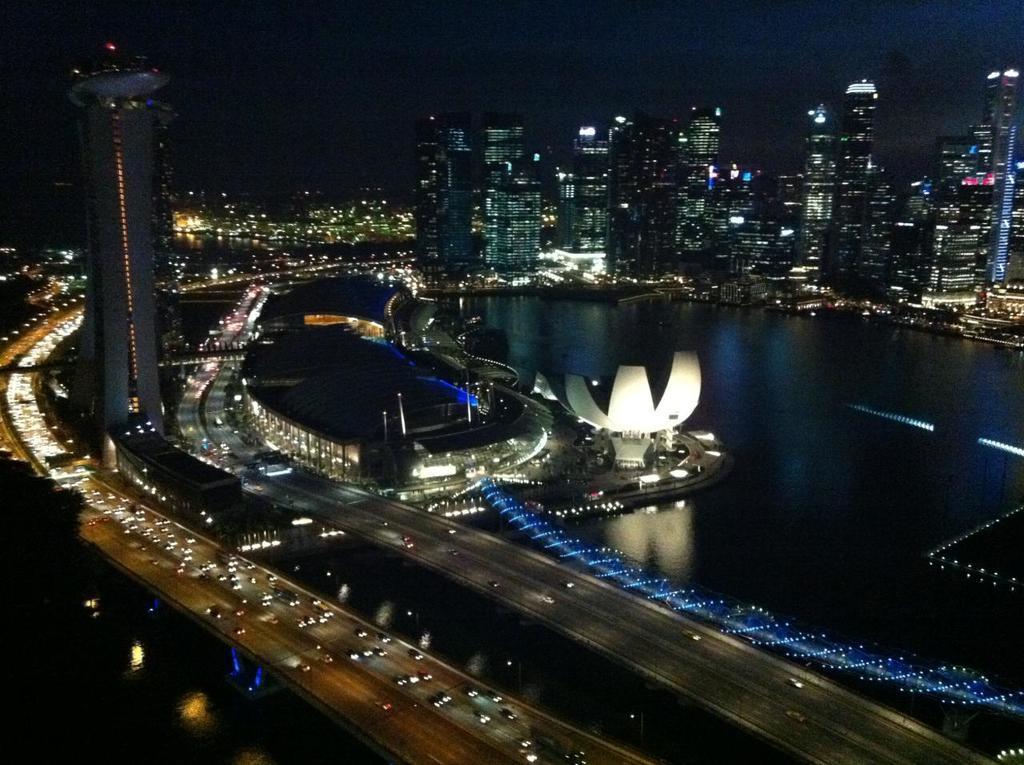In one or two sentences, can you explain what this image depicts? In the image there are vehicles on the roads, water surface, architectures and many buildings. 